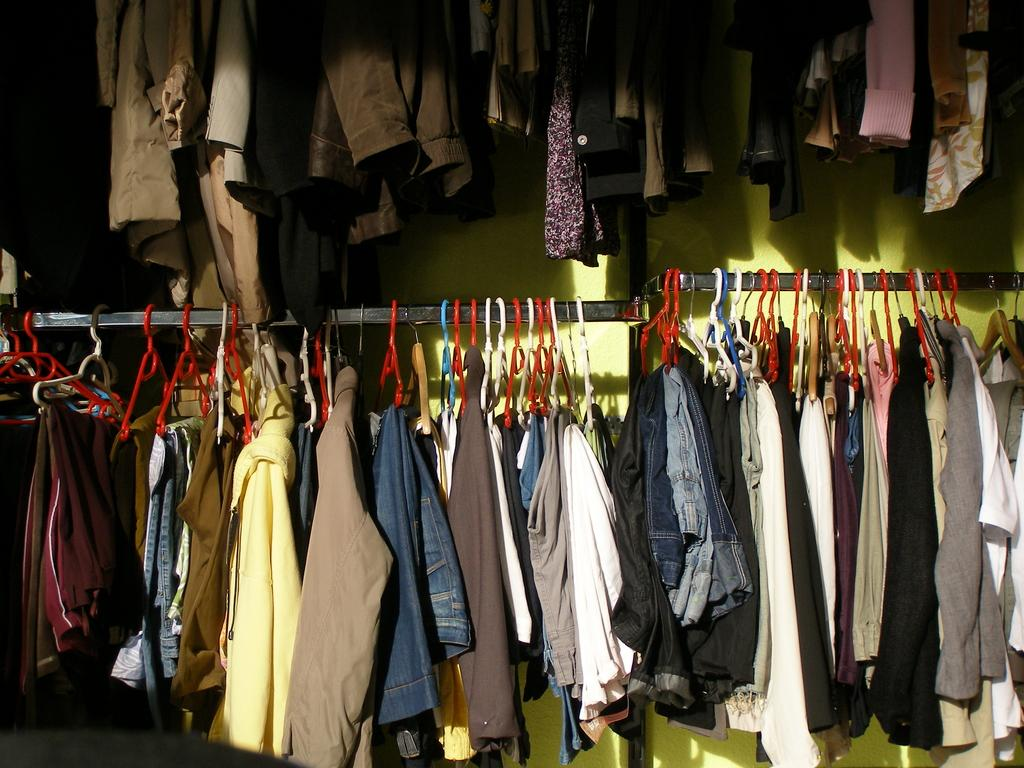What can be seen hanging on the rod in the image? There are different types of dresses hanging on a rod in the image. What colors and materials are the hangers made of? There are red, white, blue, and wooden hangers hanging on the rod. What is visible in the background of the image? There is a wall visible at the back of the image. Can you see any examples of writing on the dresses in the image? There is no writing visible on the dresses in the image. Is there a kettle present in the image? There is no kettle visible in the image; it only features dresses hanging on a rod with various hangers. 